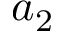Convert formula to latex. <formula><loc_0><loc_0><loc_500><loc_500>a _ { 2 }</formula> 